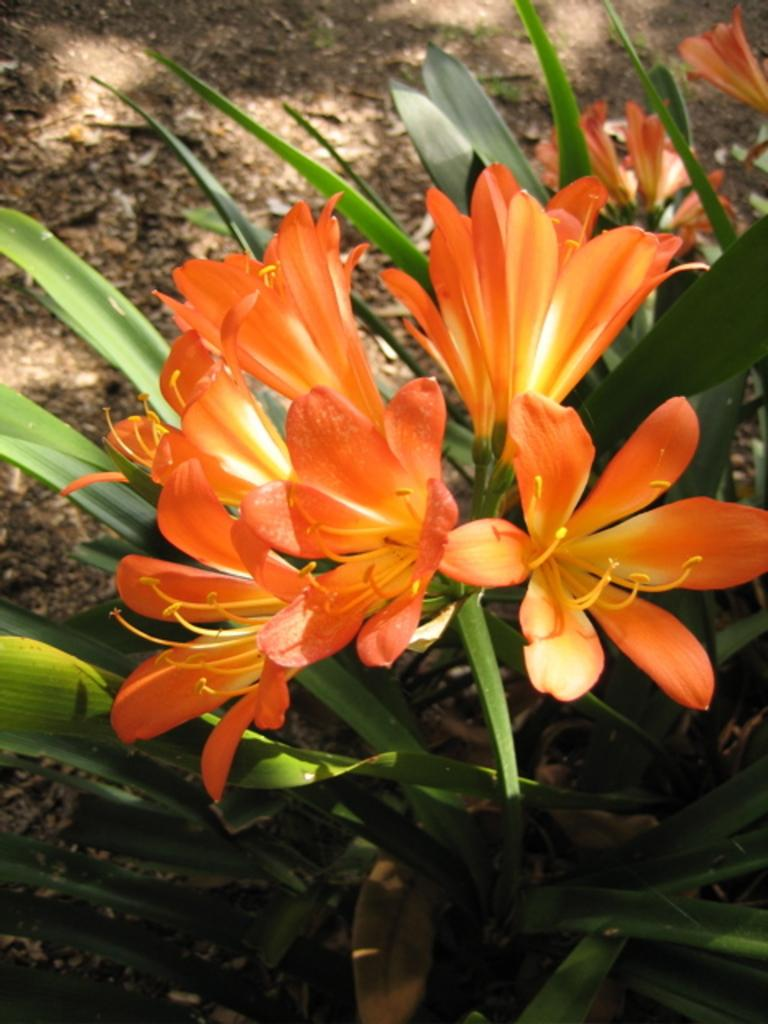What type of plants can be seen in the image? There are orange color flower plants in the image. How many bees can be seen collecting pollen from the flowers in the image? There are no bees present in the image; it only features orange color flower plants. What type of key is used to unlock the door in the image? There is no door or key present in the image; it only features orange color flower plants. 